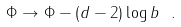Convert formula to latex. <formula><loc_0><loc_0><loc_500><loc_500>\Phi \rightarrow \Phi - ( d - 2 ) \log b \ .</formula> 